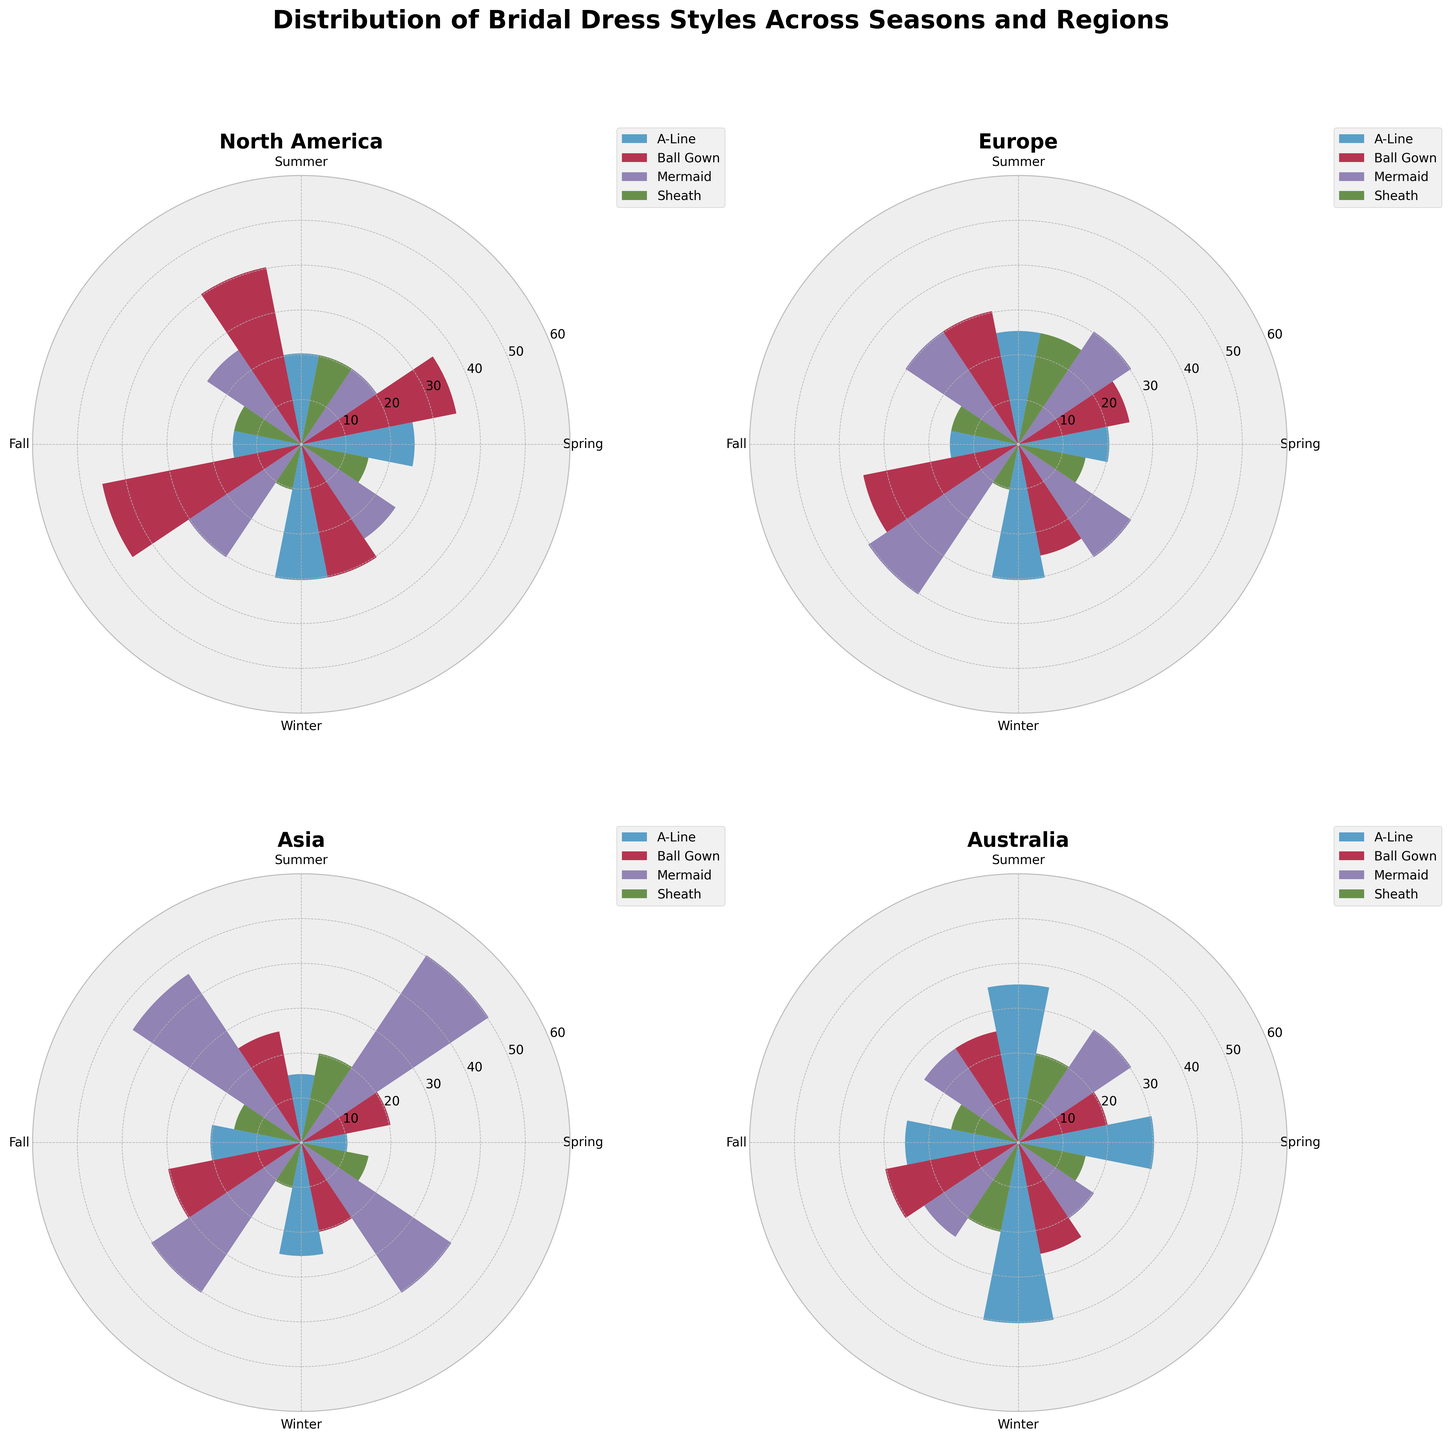Which region shows the highest preference for Mermaid style in Fall? To determine this, locate the regions' polar plots for the Fall season, then compare the Mermaid style values in those segments. North America shows the highest preference for Mermaid style with a value of 30.
Answer: North America Which bridal dress style has a consistent preference across all seasons in Europe? Observe each season's values for all bridal dress styles in Europe. A-Line has varying preferences, while Ball Gown increases slightly, Mermaid has the most consistency with minimal variation across seasons (30, 30, 40, 30).
Answer: Mermaid What's the average preference for the Sheath style in Asia? Sum the Sheath values across all seasons in Asia (20 + 15 + 10 + 15), then divide by the number of seasons (4). That's (20 + 15 + 10 + 15) / 4 = 60 / 4 = 15.
Answer: 15 Which style is least popular in Australia during Winter? Check the Winter segment in Australia's polar plot. The values are 40 (A-Line), 25 (Ball Gown), 20 (Mermaid), and 15 (Sheath). This shows Sheath is least popular.
Answer: Sheath Compare the preference for Ball Gown style in Spring between North America and Europe. Look at the Spring season values for Ball Gown style in both regions' segments. North America is 35, and Europe is 25. North America has a higher preference.
Answer: North America Which season sees a peak in the preference for A-Line style in Australia? Assess A-Line values across all seasons in Australia. The values are 30 (Spring), 35 (Summer), 25 (Fall), and 40 (Winter). The peak is during Winter.
Answer: Winter Is there a region where the Sheath style preference remains constant across all seasons? Check the Sheath values for each region and season. Only Europe's Sheath preferences remain constant across all seasons at 15.
Answer: Europe Which region sees the biggest increase in Mermaid style preference from Spring to Fall? Compare the Spring and Fall values for Mermaid style across all regions. North America: 20 to 30, Europe: 30 to 40, Asia: 50 to 40, Australia: 30 to 25). Europe has the biggest increase (10).
Answer: Europe What is the difference in preference for the Ball Gown style between Winter and Summer in North America? Subtract the Ball Gown value in Winter from the value in Summer for North America. That's 30 - 40 = -10. This indicates a 10-unit decrease.
Answer: -10 